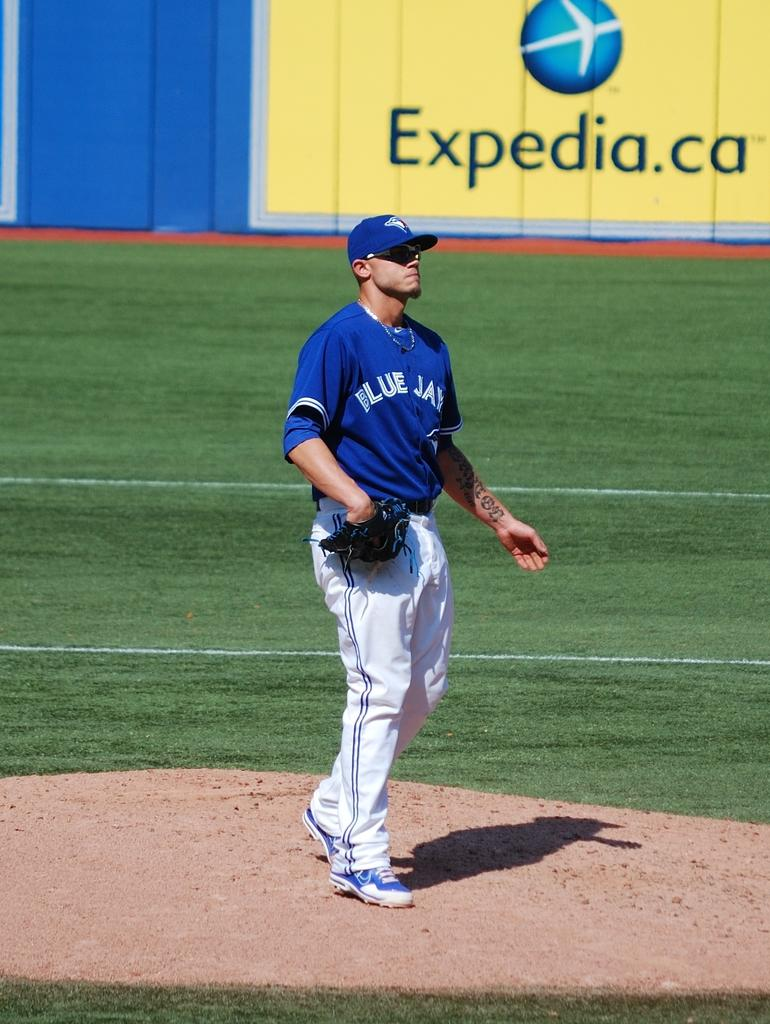<image>
Write a terse but informative summary of the picture. Baseball player standing on the pitchers mound in front of a wall sign that has Expedia.ca in black lettering. 